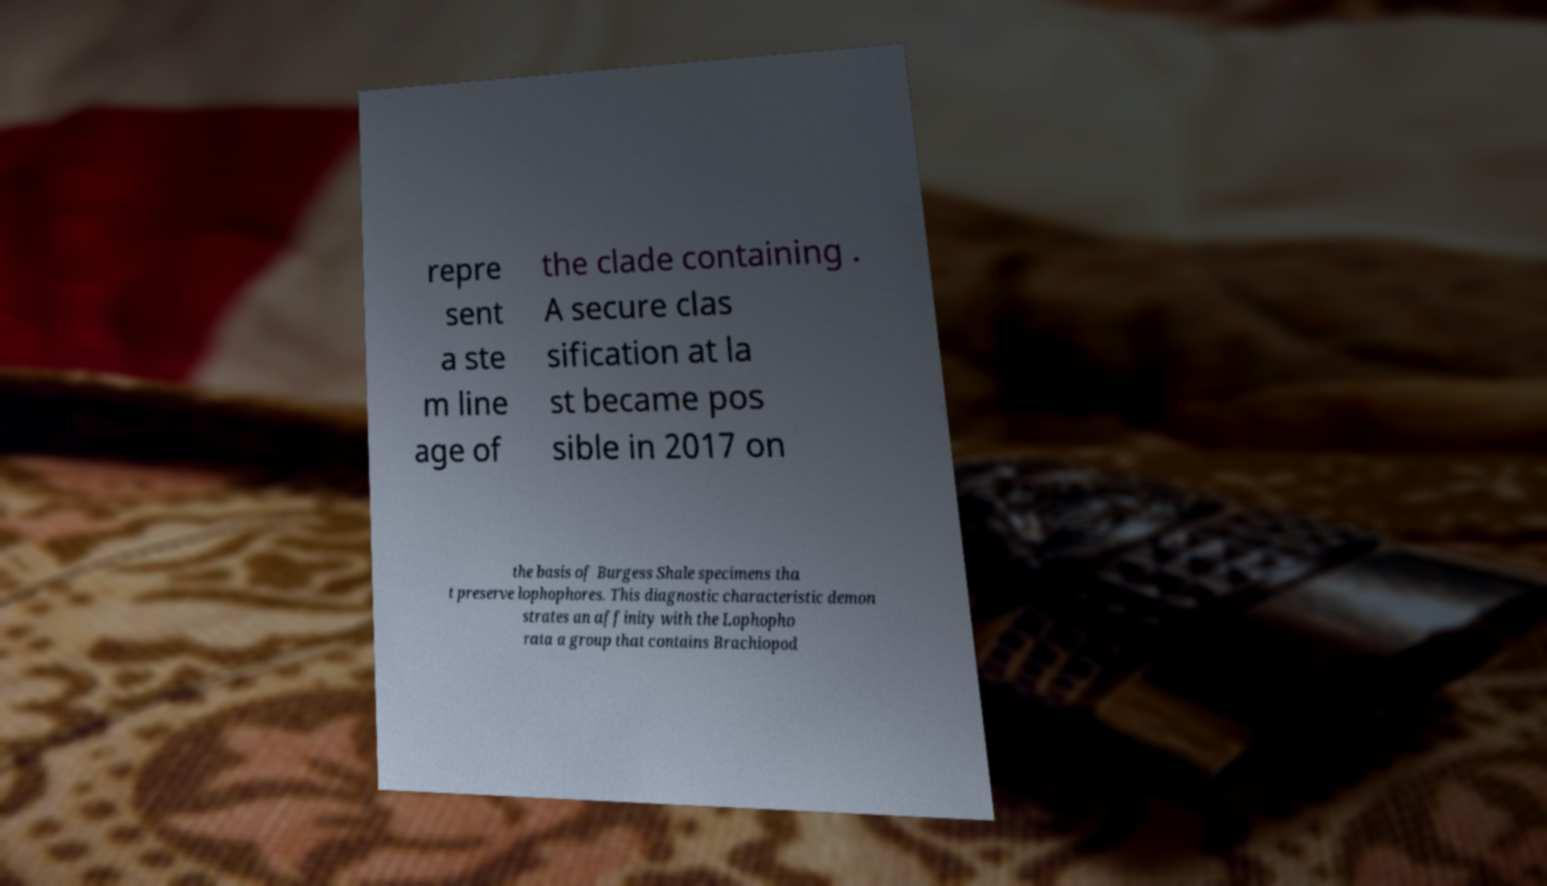What messages or text are displayed in this image? I need them in a readable, typed format. repre sent a ste m line age of the clade containing . A secure clas sification at la st became pos sible in 2017 on the basis of Burgess Shale specimens tha t preserve lophophores. This diagnostic characteristic demon strates an affinity with the Lophopho rata a group that contains Brachiopod 